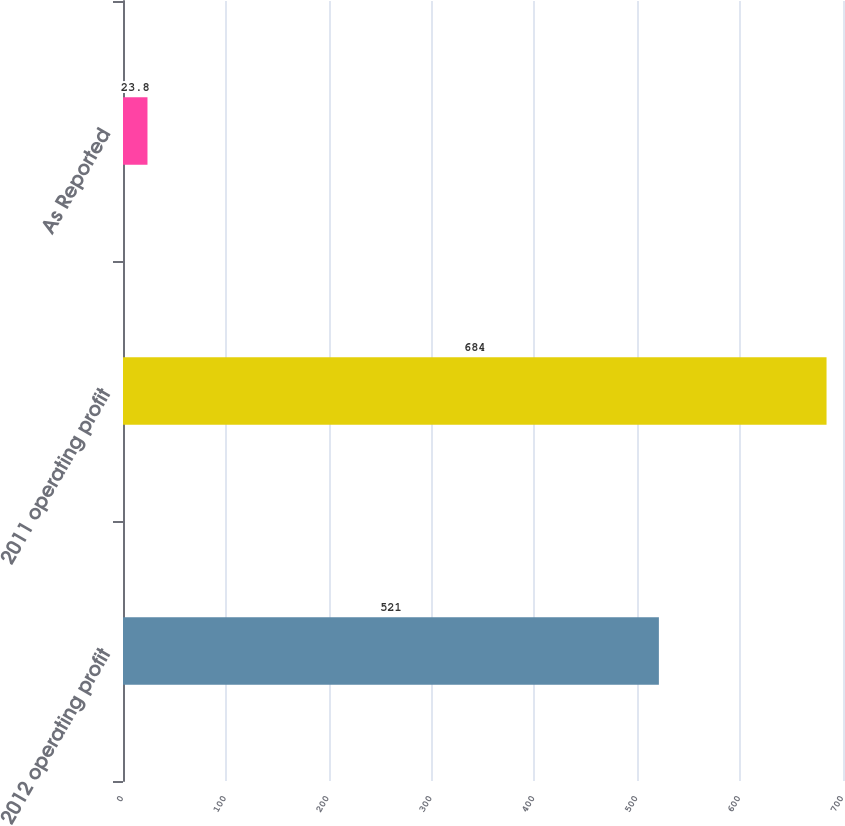Convert chart to OTSL. <chart><loc_0><loc_0><loc_500><loc_500><bar_chart><fcel>2012 operating profit<fcel>2011 operating profit<fcel>As Reported<nl><fcel>521<fcel>684<fcel>23.8<nl></chart> 